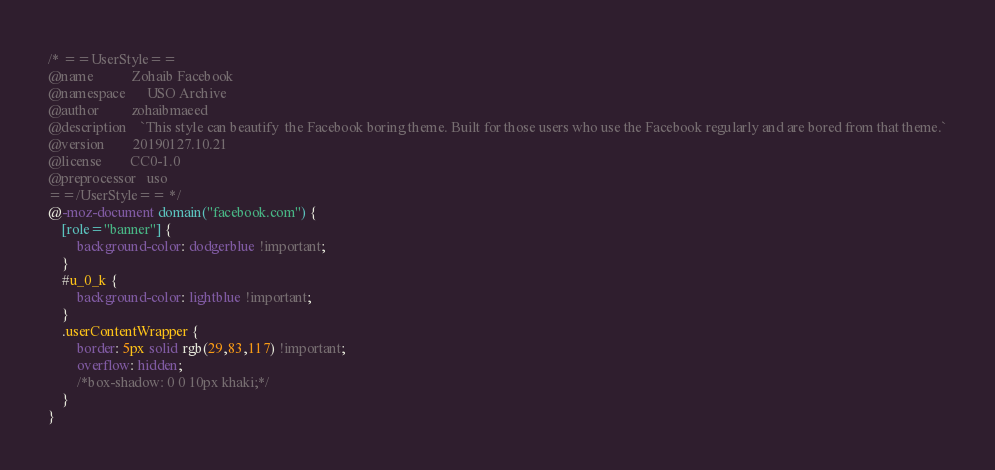<code> <loc_0><loc_0><loc_500><loc_500><_CSS_>/* ==UserStyle==
@name           Zohaib Facebook
@namespace      USO Archive
@author         zohaibmaeed
@description    `This style can beautify  the Facebook boring theme. Built for those users who use the Facebook regularly and are bored from that theme.`
@version        20190127.10.21
@license        CC0-1.0
@preprocessor   uso
==/UserStyle== */
@-moz-document domain("facebook.com") {
    [role="banner"] {
        background-color: dodgerblue !important;
    }
    #u_0_k {
        background-color: lightblue !important;
    }
    .userContentWrapper {
        border: 5px solid rgb(29,83,117) !important;
        overflow: hidden;
        /*box-shadow: 0 0 10px khaki;*/
    }
}</code> 